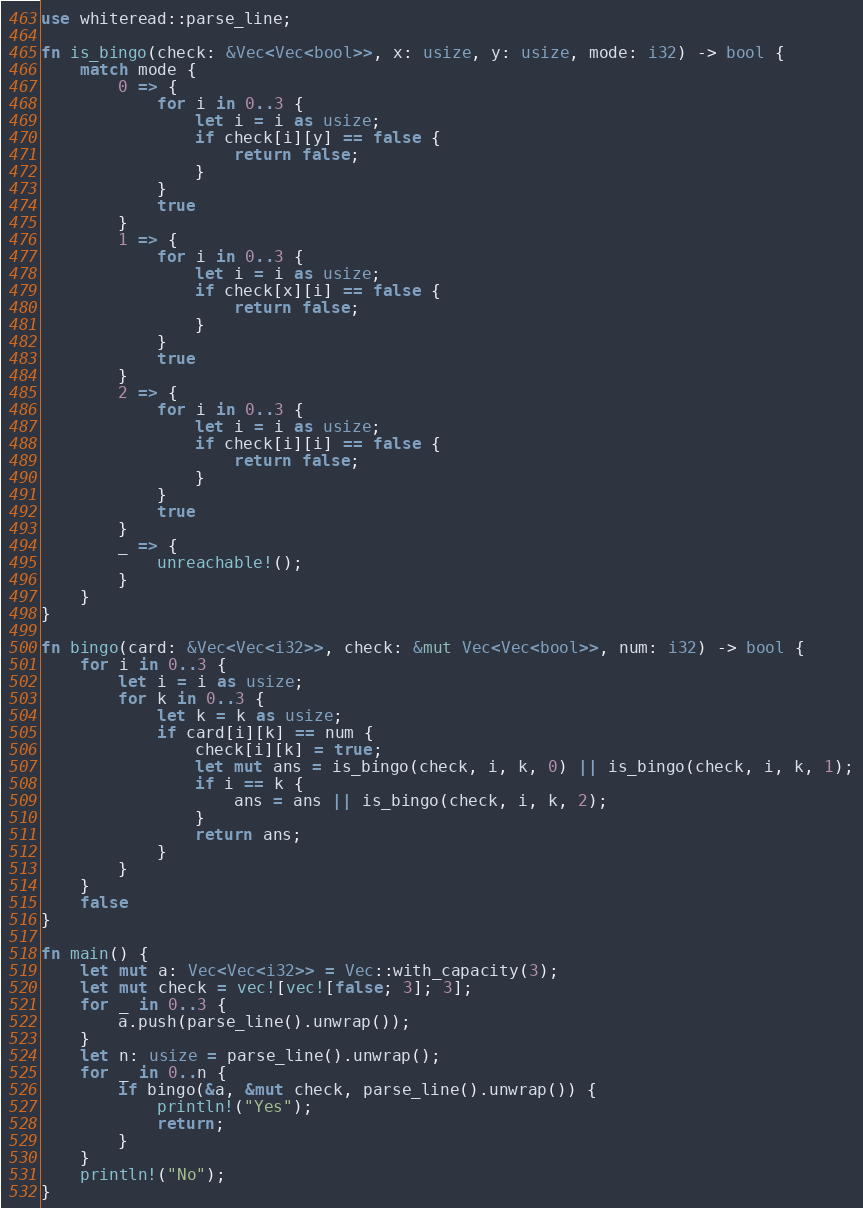Convert code to text. <code><loc_0><loc_0><loc_500><loc_500><_Rust_>use whiteread::parse_line;

fn is_bingo(check: &Vec<Vec<bool>>, x: usize, y: usize, mode: i32) -> bool {
    match mode {
        0 => {
            for i in 0..3 {
                let i = i as usize;
                if check[i][y] == false {
                    return false;
                }
            }
            true
        }
        1 => {
            for i in 0..3 {
                let i = i as usize;
                if check[x][i] == false {
                    return false;
                }
            }
            true
        }
        2 => {
            for i in 0..3 {
                let i = i as usize;
                if check[i][i] == false {
                    return false;
                }
            }
            true
        }
        _ => {
            unreachable!();
        }
    }
}

fn bingo(card: &Vec<Vec<i32>>, check: &mut Vec<Vec<bool>>, num: i32) -> bool {
    for i in 0..3 {
        let i = i as usize;
        for k in 0..3 {
            let k = k as usize;
            if card[i][k] == num {
                check[i][k] = true;
                let mut ans = is_bingo(check, i, k, 0) || is_bingo(check, i, k, 1);
                if i == k {
                    ans = ans || is_bingo(check, i, k, 2);
                }
                return ans;
            }
        }
    }
    false
}

fn main() {
    let mut a: Vec<Vec<i32>> = Vec::with_capacity(3);
    let mut check = vec![vec![false; 3]; 3];
    for _ in 0..3 {
        a.push(parse_line().unwrap());
    }
    let n: usize = parse_line().unwrap();
    for _ in 0..n {
        if bingo(&a, &mut check, parse_line().unwrap()) {
            println!("Yes");
            return;
        }
    }
    println!("No");
}
</code> 